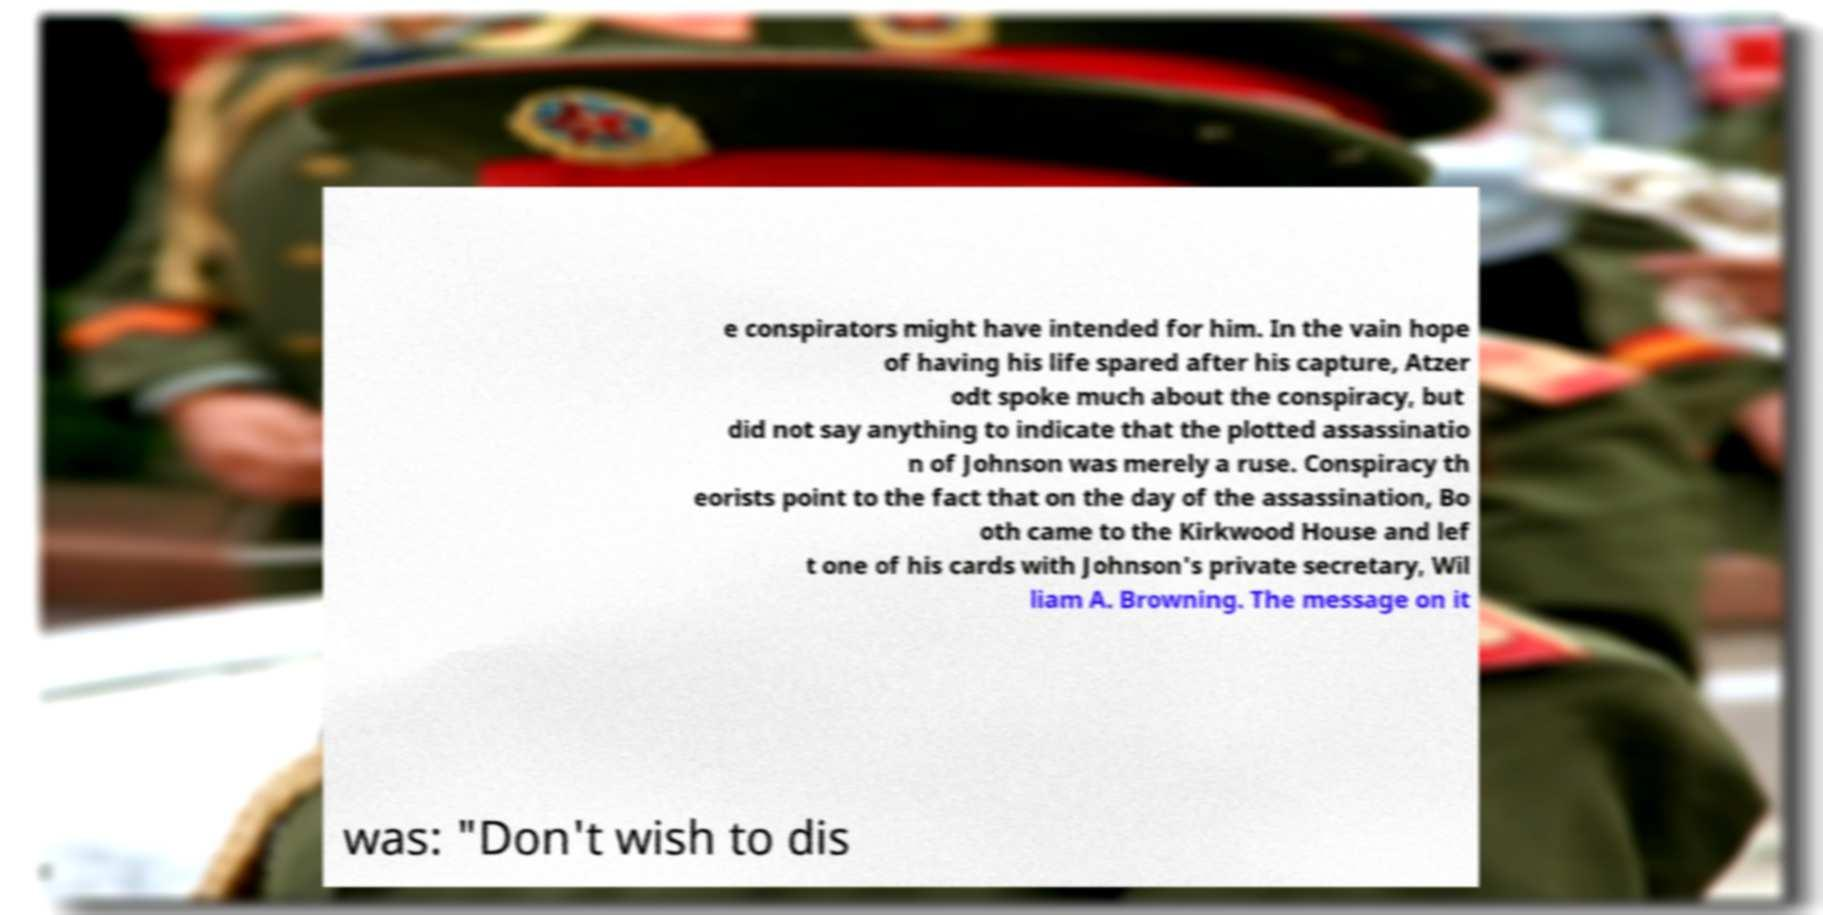Could you assist in decoding the text presented in this image and type it out clearly? e conspirators might have intended for him. In the vain hope of having his life spared after his capture, Atzer odt spoke much about the conspiracy, but did not say anything to indicate that the plotted assassinatio n of Johnson was merely a ruse. Conspiracy th eorists point to the fact that on the day of the assassination, Bo oth came to the Kirkwood House and lef t one of his cards with Johnson's private secretary, Wil liam A. Browning. The message on it was: "Don't wish to dis 